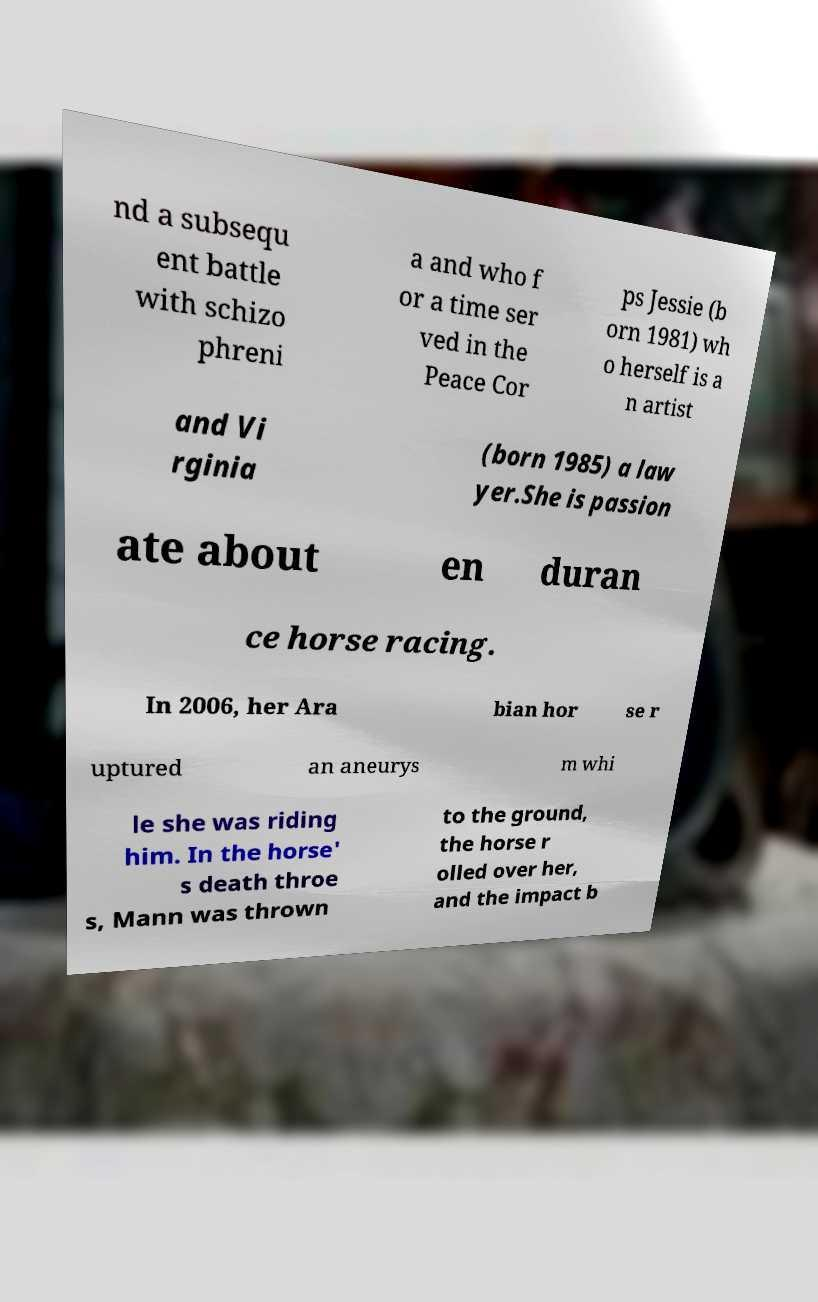Could you extract and type out the text from this image? nd a subsequ ent battle with schizo phreni a and who f or a time ser ved in the Peace Cor ps Jessie (b orn 1981) wh o herself is a n artist and Vi rginia (born 1985) a law yer.She is passion ate about en duran ce horse racing. In 2006, her Ara bian hor se r uptured an aneurys m whi le she was riding him. In the horse' s death throe s, Mann was thrown to the ground, the horse r olled over her, and the impact b 